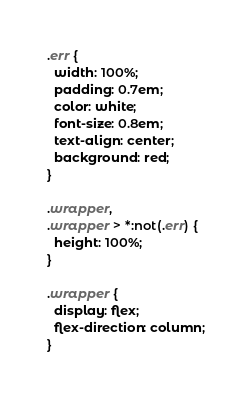Convert code to text. <code><loc_0><loc_0><loc_500><loc_500><_CSS_>.err {
  width: 100%;
  padding: 0.7em;
  color: white;
  font-size: 0.8em;
  text-align: center;
  background: red;
}

.wrapper,
.wrapper > *:not(.err) {
  height: 100%;
}

.wrapper {
  display: flex;
  flex-direction: column;
}
</code> 